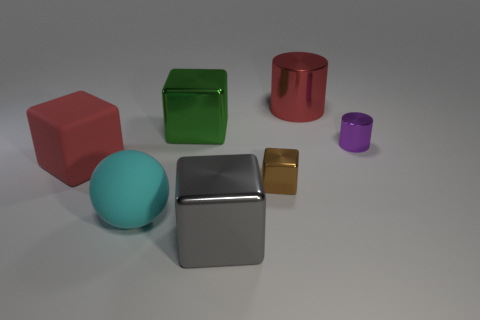Subtract all large cubes. How many cubes are left? 1 Add 2 big rubber spheres. How many objects exist? 9 Subtract all green blocks. How many blocks are left? 3 Subtract 1 cubes. How many cubes are left? 3 Subtract 0 green balls. How many objects are left? 7 Subtract all cylinders. How many objects are left? 5 Subtract all gray blocks. Subtract all gray cylinders. How many blocks are left? 3 Subtract all purple spheres. How many green cylinders are left? 0 Subtract all tiny red cylinders. Subtract all red shiny cylinders. How many objects are left? 6 Add 6 gray objects. How many gray objects are left? 7 